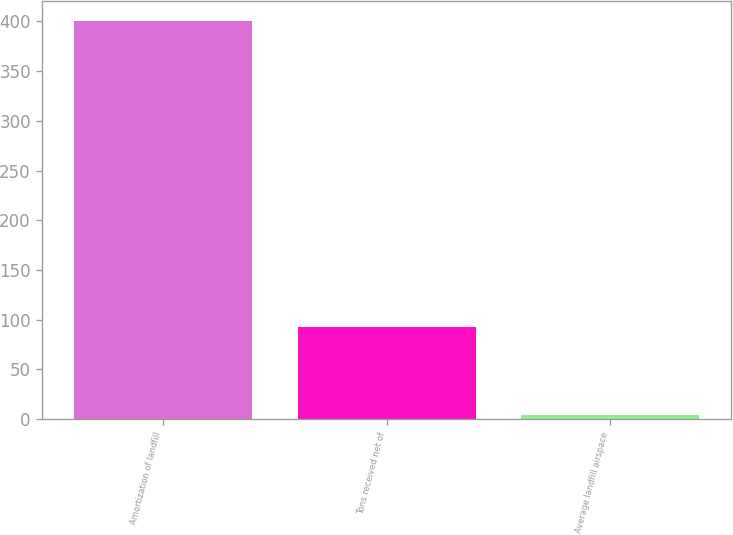Convert chart. <chart><loc_0><loc_0><loc_500><loc_500><bar_chart><fcel>Amortization of landfill<fcel>Tons received net of<fcel>Average landfill airspace<nl><fcel>400<fcel>93<fcel>4.29<nl></chart> 